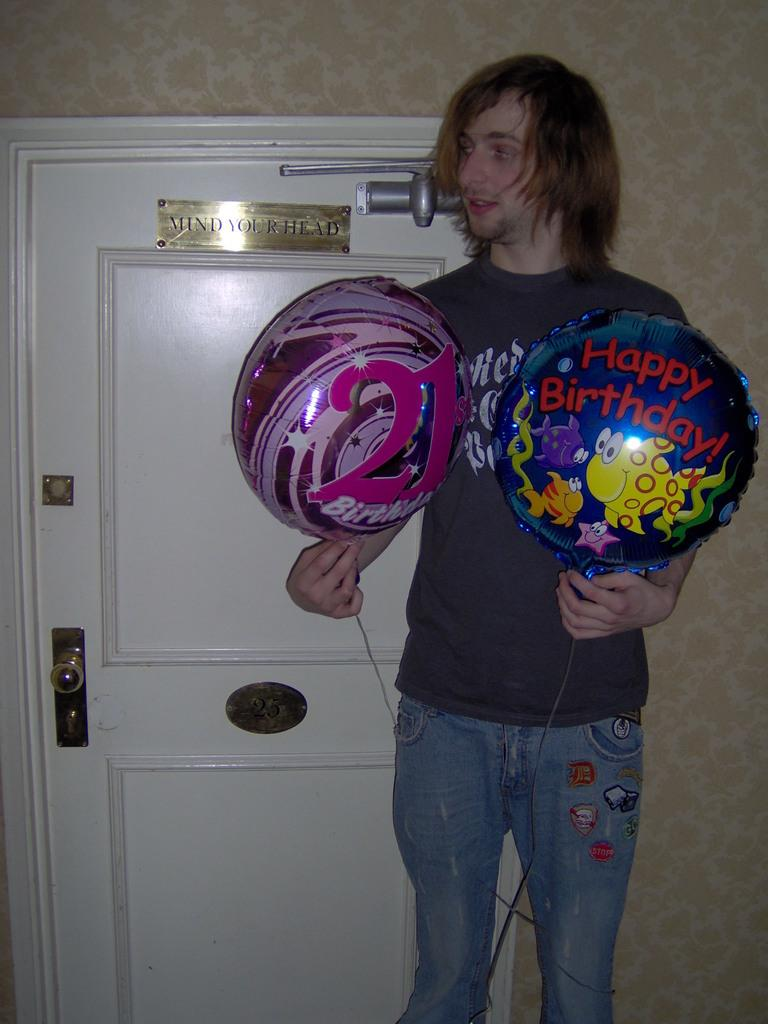What is the person in the image holding? The person is holding balloons in the image. What can be seen in the background of the image? There is a wall, a door, and boards in the background of the image. What type of stone is being used for the competition in the image? There is no competition or stone present in the image. 